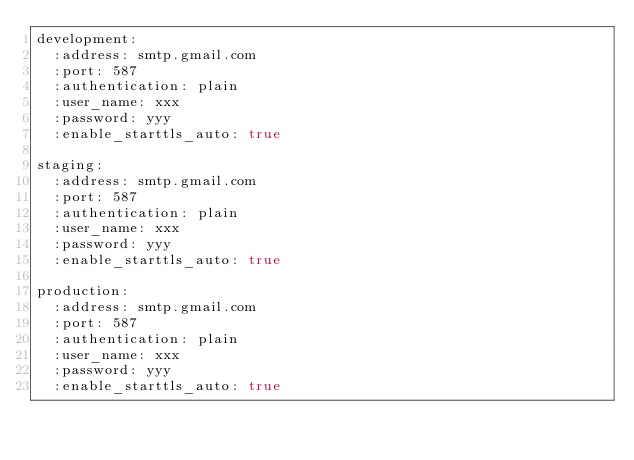Convert code to text. <code><loc_0><loc_0><loc_500><loc_500><_YAML_>development:
  :address: smtp.gmail.com
  :port: 587
  :authentication: plain
  :user_name: xxx
  :password: yyy
  :enable_starttls_auto: true

staging:
  :address: smtp.gmail.com
  :port: 587
  :authentication: plain
  :user_name: xxx
  :password: yyy
  :enable_starttls_auto: true

production:
  :address: smtp.gmail.com
  :port: 587
  :authentication: plain
  :user_name: xxx
  :password: yyy
  :enable_starttls_auto: true
</code> 